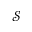<formula> <loc_0><loc_0><loc_500><loc_500>\mathcal { S }</formula> 